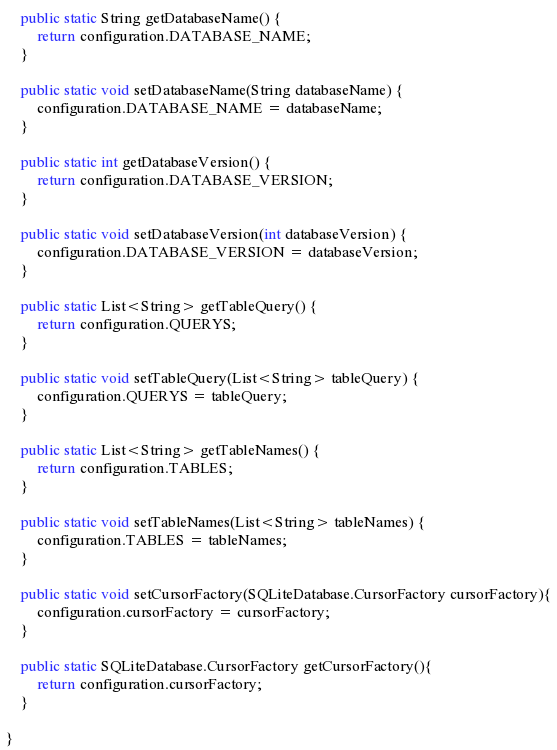<code> <loc_0><loc_0><loc_500><loc_500><_Java_>
    public static String getDatabaseName() {
        return configuration.DATABASE_NAME;
    }

    public static void setDatabaseName(String databaseName) {
        configuration.DATABASE_NAME = databaseName;
    }

    public static int getDatabaseVersion() {
        return configuration.DATABASE_VERSION;
    }

    public static void setDatabaseVersion(int databaseVersion) {
        configuration.DATABASE_VERSION = databaseVersion;
    }

    public static List<String> getTableQuery() {
        return configuration.QUERYS;
    }

    public static void setTableQuery(List<String> tableQuery) {
        configuration.QUERYS = tableQuery;
    }

    public static List<String> getTableNames() {
        return configuration.TABLES;
    }

    public static void setTableNames(List<String> tableNames) {
        configuration.TABLES = tableNames;
    }

    public static void setCursorFactory(SQLiteDatabase.CursorFactory cursorFactory){
        configuration.cursorFactory = cursorFactory;
    }

    public static SQLiteDatabase.CursorFactory getCursorFactory(){
        return configuration.cursorFactory;
    }

}
</code> 